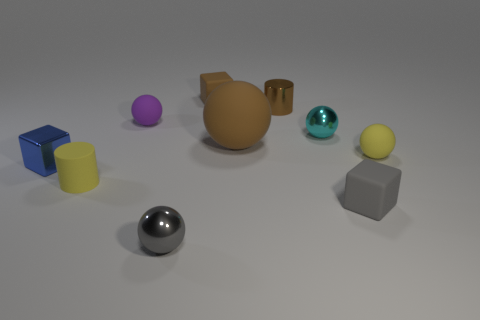Subtract all small gray metal spheres. How many spheres are left? 4 Subtract all blue blocks. How many blocks are left? 2 Subtract 2 blocks. How many blocks are left? 1 Subtract all cylinders. How many objects are left? 8 Subtract all brown spheres. How many brown blocks are left? 1 Subtract all gray shiny objects. Subtract all shiny spheres. How many objects are left? 7 Add 5 brown metal cylinders. How many brown metal cylinders are left? 6 Add 8 tiny cyan metal objects. How many tiny cyan metal objects exist? 9 Subtract 0 blue cylinders. How many objects are left? 10 Subtract all cyan blocks. Subtract all blue cylinders. How many blocks are left? 3 